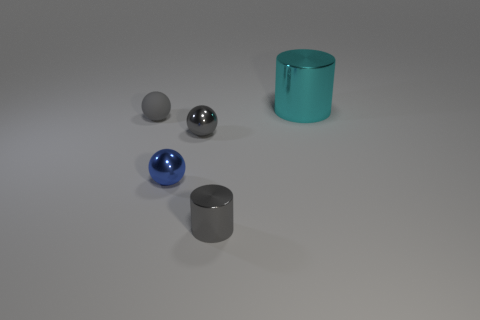Add 3 tiny green cylinders. How many objects exist? 8 Subtract all balls. How many objects are left? 2 Subtract 0 red cubes. How many objects are left? 5 Subtract all big cubes. Subtract all tiny spheres. How many objects are left? 2 Add 2 metal balls. How many metal balls are left? 4 Add 1 small shiny cylinders. How many small shiny cylinders exist? 2 